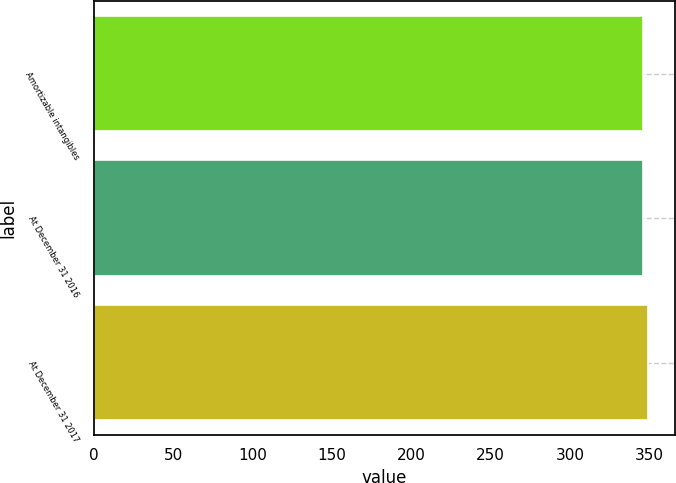<chart> <loc_0><loc_0><loc_500><loc_500><bar_chart><fcel>Amortizable intangibles<fcel>At December 31 2016<fcel>At December 31 2017<nl><fcel>346<fcel>346.3<fcel>349<nl></chart> 